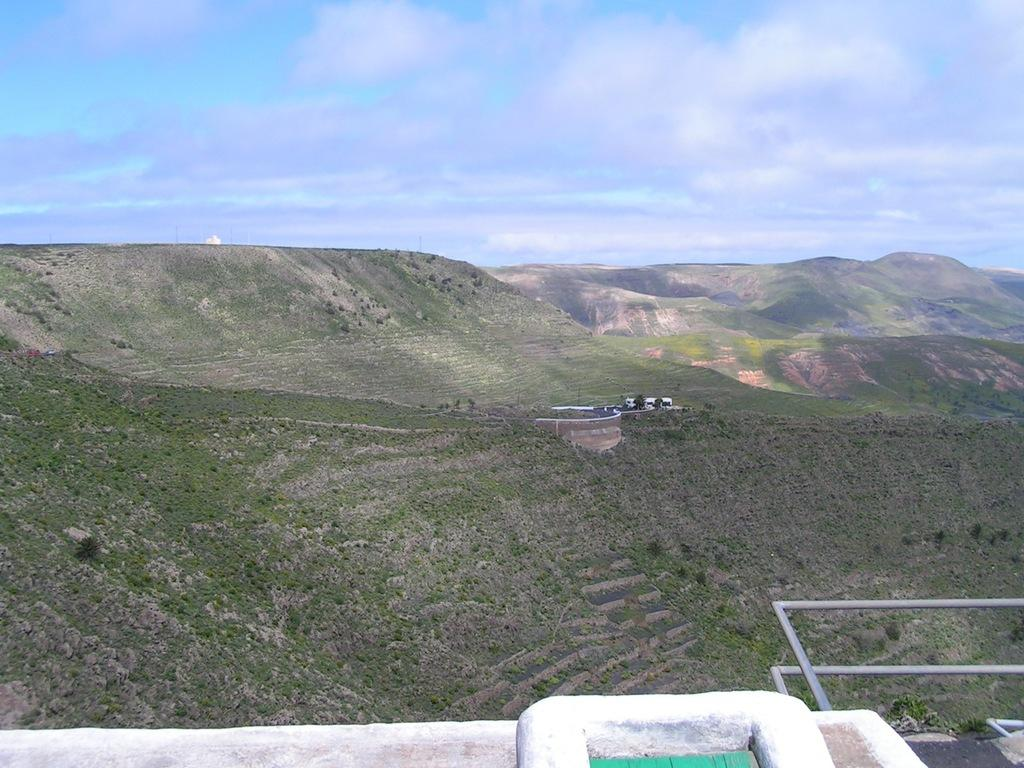What type of vegetation is visible in the image? There is grass in the image. What type of natural landform can be seen in the image? There are mountains in the image. What type of man-made structure is present in the image? There is an iron railing in the image. What is visible at the top of the image? The sky is visible at the top of the image. How many pigs are sleeping on the grass in the image? There are no pigs present in the image, and therefore no sleeping pigs can be observed. What type of throat medicine is visible in the image? There is no throat medicine present in the image. 